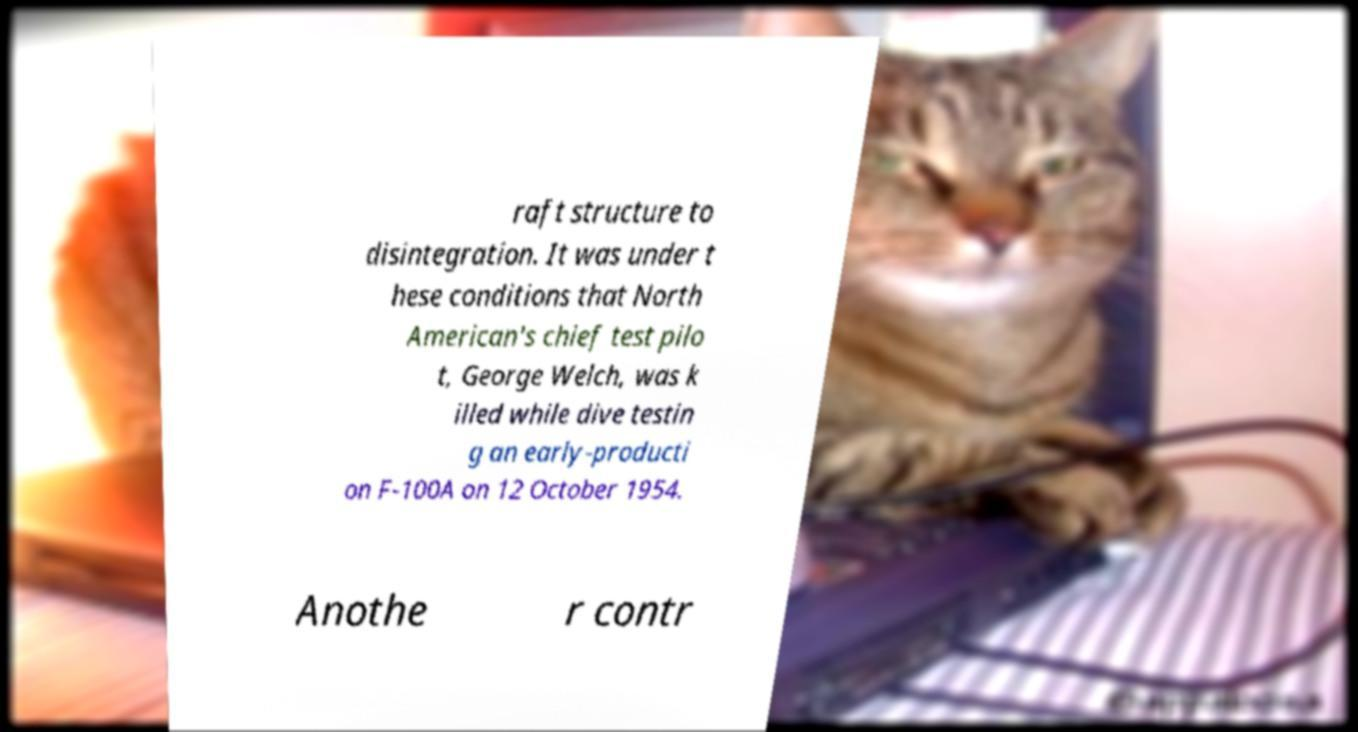I need the written content from this picture converted into text. Can you do that? raft structure to disintegration. It was under t hese conditions that North American's chief test pilo t, George Welch, was k illed while dive testin g an early-producti on F-100A on 12 October 1954. Anothe r contr 